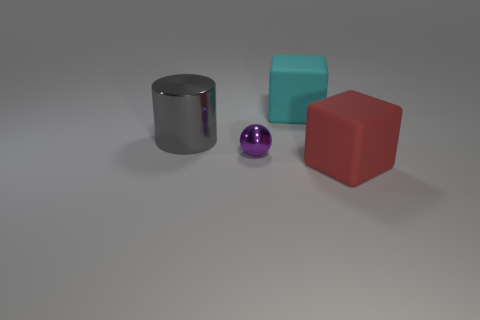Are there any tiny things that are in front of the big object that is on the left side of the matte block behind the big red object?
Offer a very short reply. Yes. Is there any other thing of the same color as the big cylinder?
Provide a short and direct response. No. There is a cube that is in front of the big cylinder; how big is it?
Ensure brevity in your answer.  Large. There is a cube that is behind the block right of the large matte cube that is behind the large red block; how big is it?
Keep it short and to the point. Large. What is the color of the block that is on the right side of the rubber thing behind the large red rubber cube?
Your answer should be compact. Red. There is a cyan thing that is the same shape as the big red matte object; what is it made of?
Your answer should be very brief. Rubber. There is a purple shiny ball; are there any small purple metallic balls in front of it?
Offer a terse response. No. How many big purple metallic objects are there?
Your response must be concise. 0. How many cubes are on the right side of the large rubber object behind the tiny purple object?
Offer a very short reply. 1. What number of other big matte things have the same shape as the large red matte thing?
Your answer should be compact. 1. 